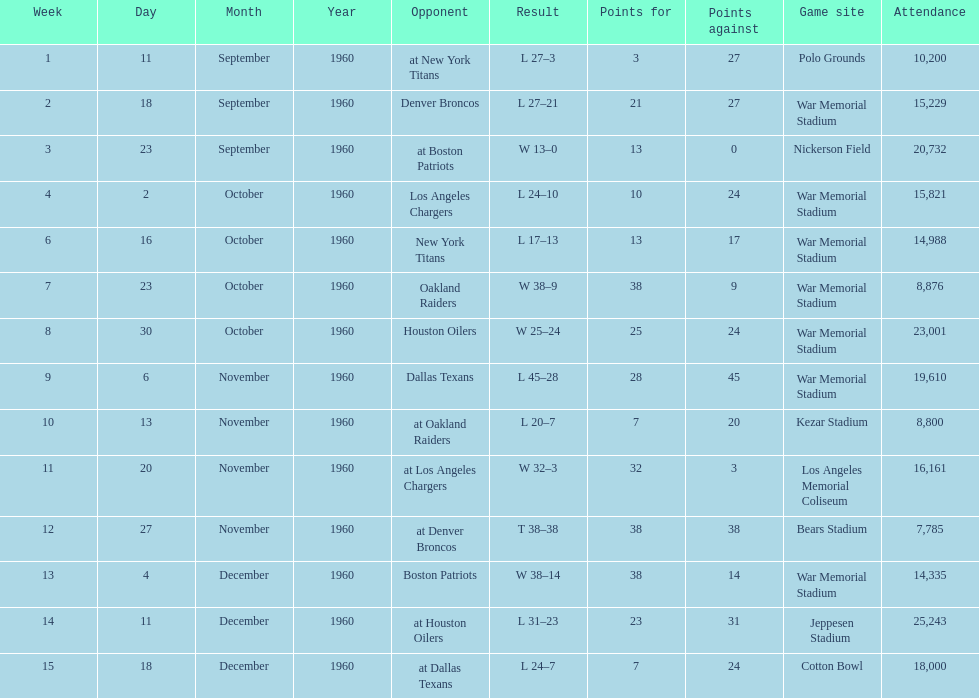The total number of games played at war memorial stadium was how many? 7. 